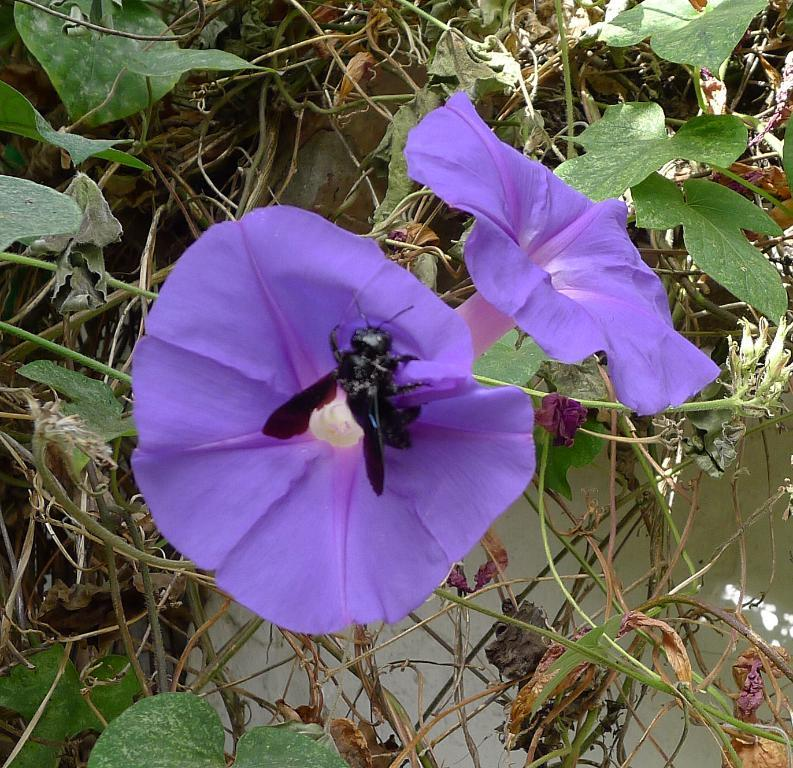What types of living organisms can be seen in the image? Plants and flowers are visible in the image. What part of the plants are in bloom? Flowers are in bloom on the plants in the image. What is visible in the background of the image? There is a wall in the background of the image. What type of creature is using its teeth to perform an action on the plants in the image? There is no creature present in the image, and therefore no such activity can be observed. 